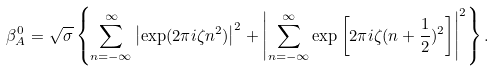Convert formula to latex. <formula><loc_0><loc_0><loc_500><loc_500>\beta _ { A } ^ { 0 } = \sqrt { \sigma } \left \{ \sum _ { n = - \infty } ^ { \infty } \left | \exp ( 2 \pi i \zeta n ^ { 2 } ) \right | ^ { 2 } + \left | \sum _ { n = - \infty } ^ { \infty } \exp \left [ 2 \pi i \zeta ( n + \frac { 1 } { 2 } ) ^ { 2 } \right ] \right | ^ { 2 } \right \} .</formula> 